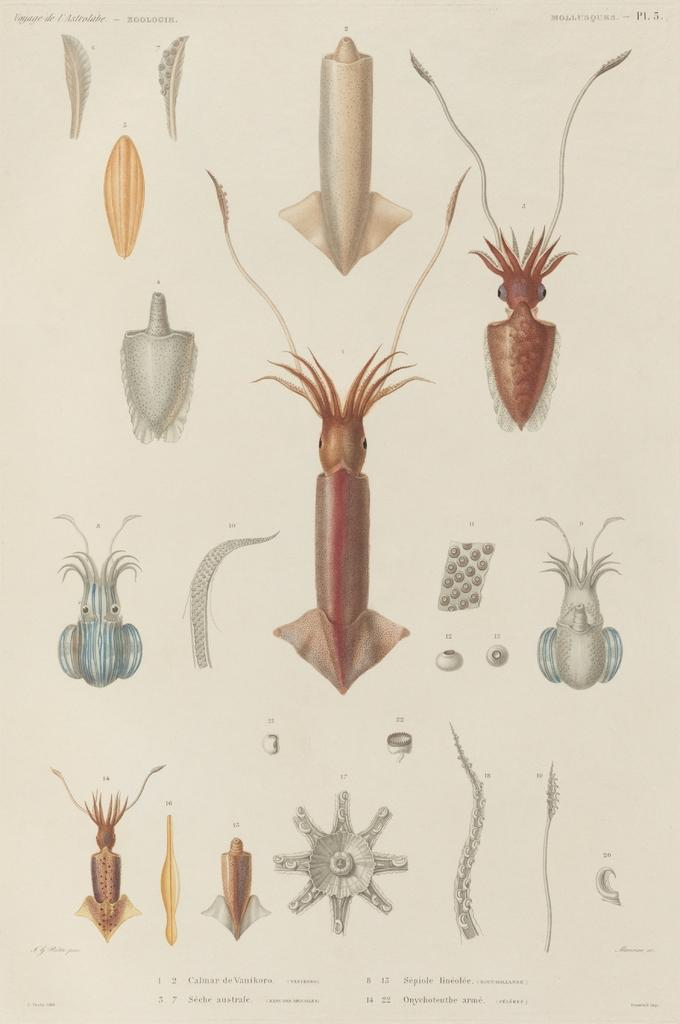What is the main subject of the image? The main subject of the image is a chart. What can be found on the chart? The chart contains structures of some things. How many berries are present on the chart in the image? There is no mention of berries in the image, as the chart contains structures of some things, but not specifically berries. 